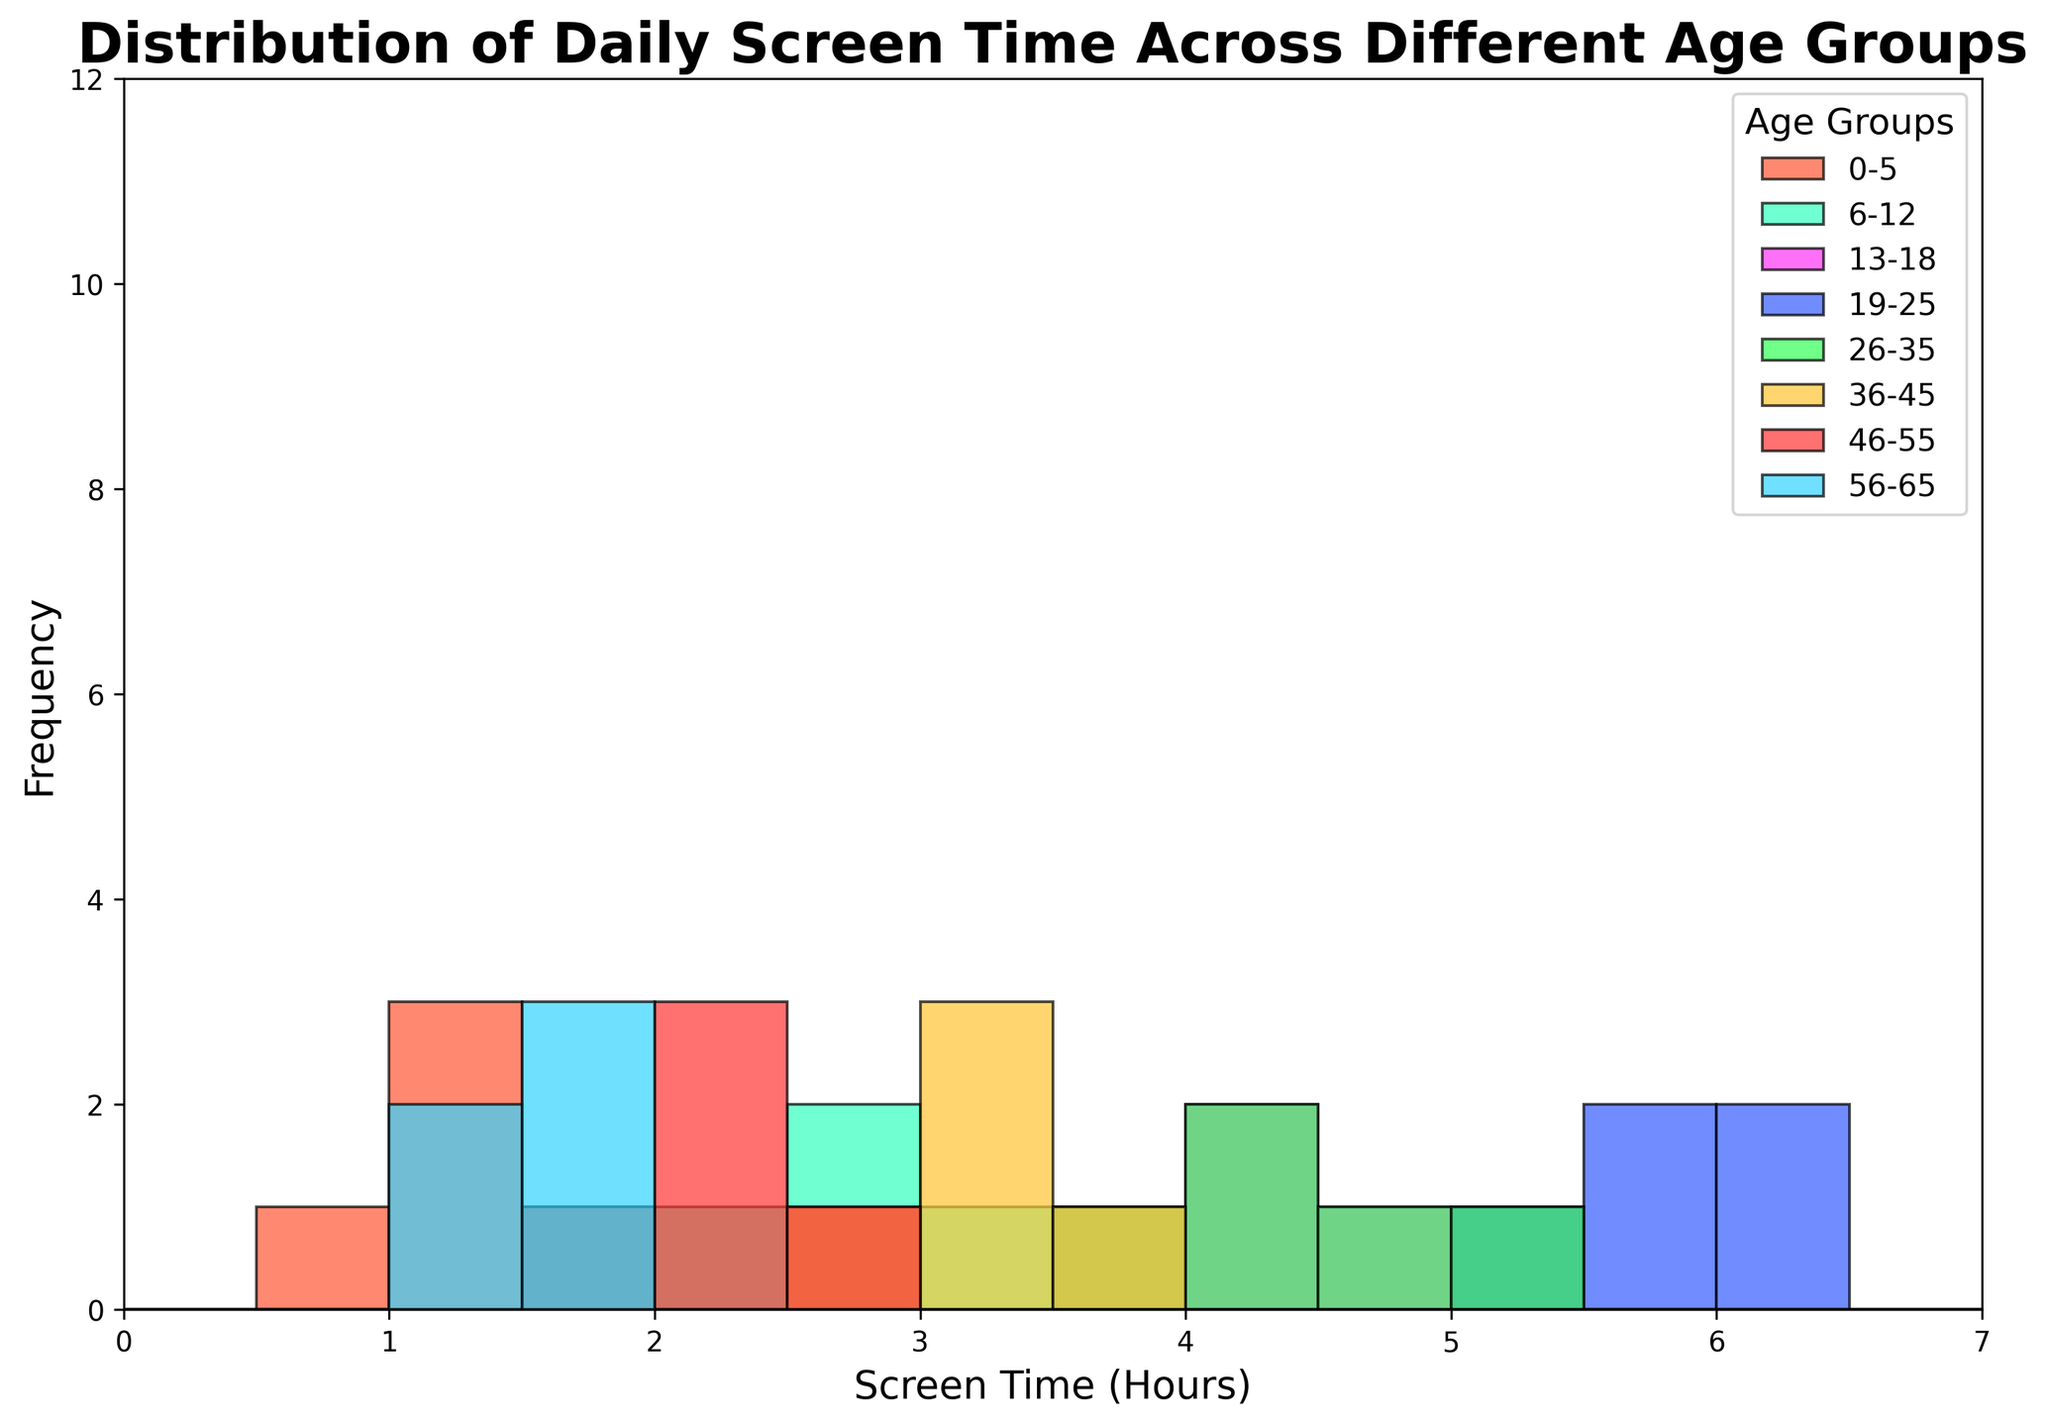what is the most common screen time range in the age group 13-18? Referring to the histogram for age group 13-18, the highest bar represents the frequency, and it occurs in the 3.5-4.0 hour range. Therefore, the most common screen time range is 3.5-4.0 hours.
Answer: 3.5-4.0 Hours Which age group has the highest average screen time? To find the age group with the highest average screen time, look for the highest bars across different age groups. The age group 19-25 shows consistently high frequencies in the higher screen time ranges (5 to 6.2 hours). Hence, 19-25 has the highest average screen time.
Answer: 19-25 How does the screen time of age group 0-5 compare to age group 76+? Both these age groups have the majority of their screen time in the lower ranges, but the 0-5 age group’s most common range is 1-1.5 hours, whereas the 76+ age group falls in the 0.3-0.6 hour range.
Answer: 0-5 > 76+ What is the median screen time of the 36-45 age group? The 36-45 age group's histogram shows the highest frequency around the 3.0-hour range. Counting up from the frequencies, the median lands at the 3.0-hour mark.
Answer: 3.0 Hours Which age group has more variance in screen time, 26-35 or 46-55? Referring to the spread of bars in the histogram, the 26-35 age group has a broader range (3.8-5.0 hours) compared to 46-55 (1.8-2.5 hours), hence more variance in screen time.
Answer: 26-35 In the 6-12 age group, are there more people with screen time above 2 hours or below 2 hours? Checking the histogram for 6-12, most of the bars (2-3 hours) are above 2 hours, with fewer bars below.
Answer: Above 2 hours Is there any overlap in screen time range between the 0-5 and 56-65 age groups? Looking at the histograms for both age groups, both show they have screen times between 1-1.5 hours, indicating overlap.
Answer: Yes What are the screen time ranges that occur exclusively in the 19-25 age group? Observing the histogram, the 19-25 age group uniquely shows screen times in the 6.0-6.2 range, unlike other age groups.
Answer: 6.0-6.2 Hours How does the frequency of screen time between 0.8-1 hours compare between 66-75 and 0-5 age groups? The 66-75 age group shows a frequency bar at 0.8-1 hours, whereas the 0-5 group does not actively show in this range.
Answer: 66-75 > 0-5 